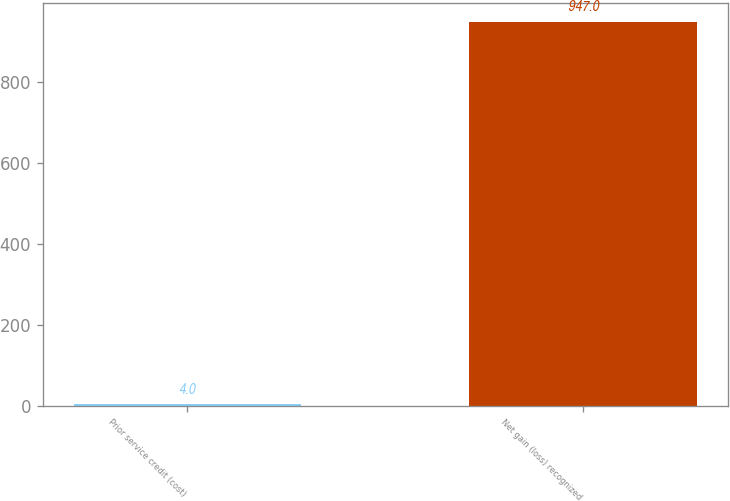<chart> <loc_0><loc_0><loc_500><loc_500><bar_chart><fcel>Prior service credit (cost)<fcel>Net gain (loss) recognized<nl><fcel>4<fcel>947<nl></chart> 